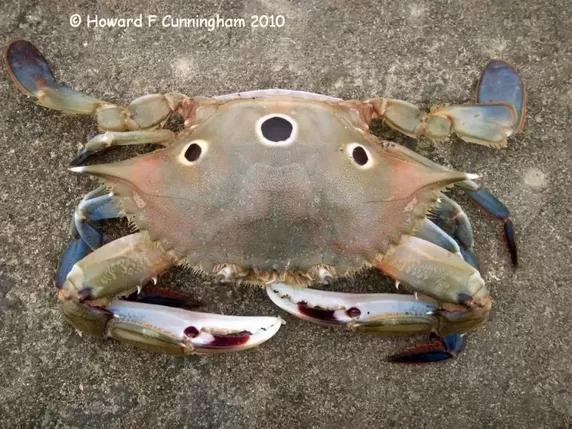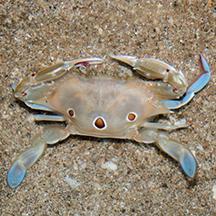The first image is the image on the left, the second image is the image on the right. For the images shown, is this caption "All the crabs are on sand." true? Answer yes or no. Yes. 